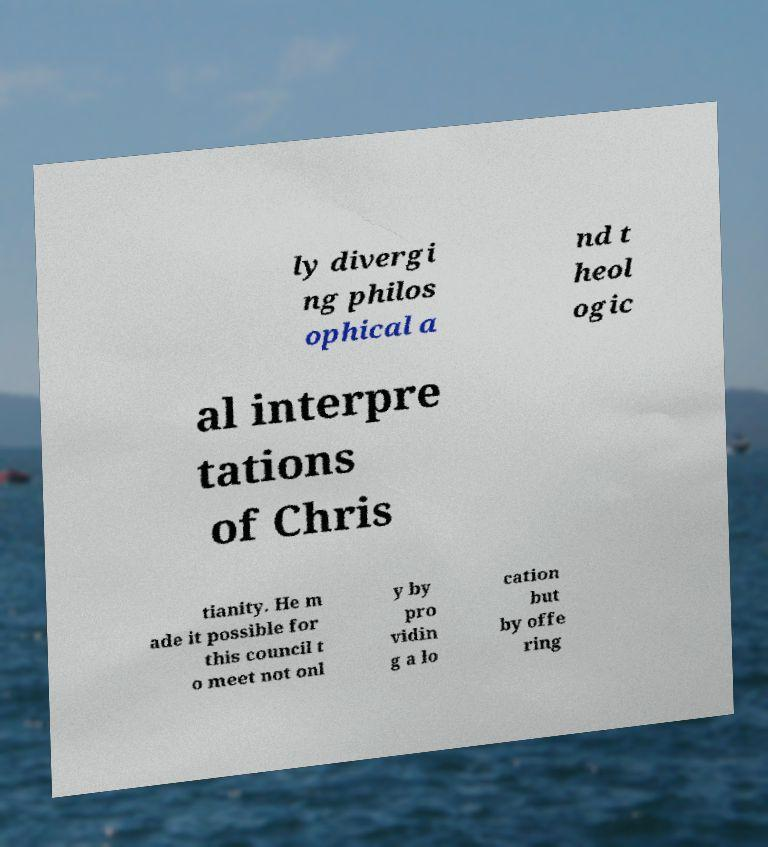Could you assist in decoding the text presented in this image and type it out clearly? ly divergi ng philos ophical a nd t heol ogic al interpre tations of Chris tianity. He m ade it possible for this council t o meet not onl y by pro vidin g a lo cation but by offe ring 